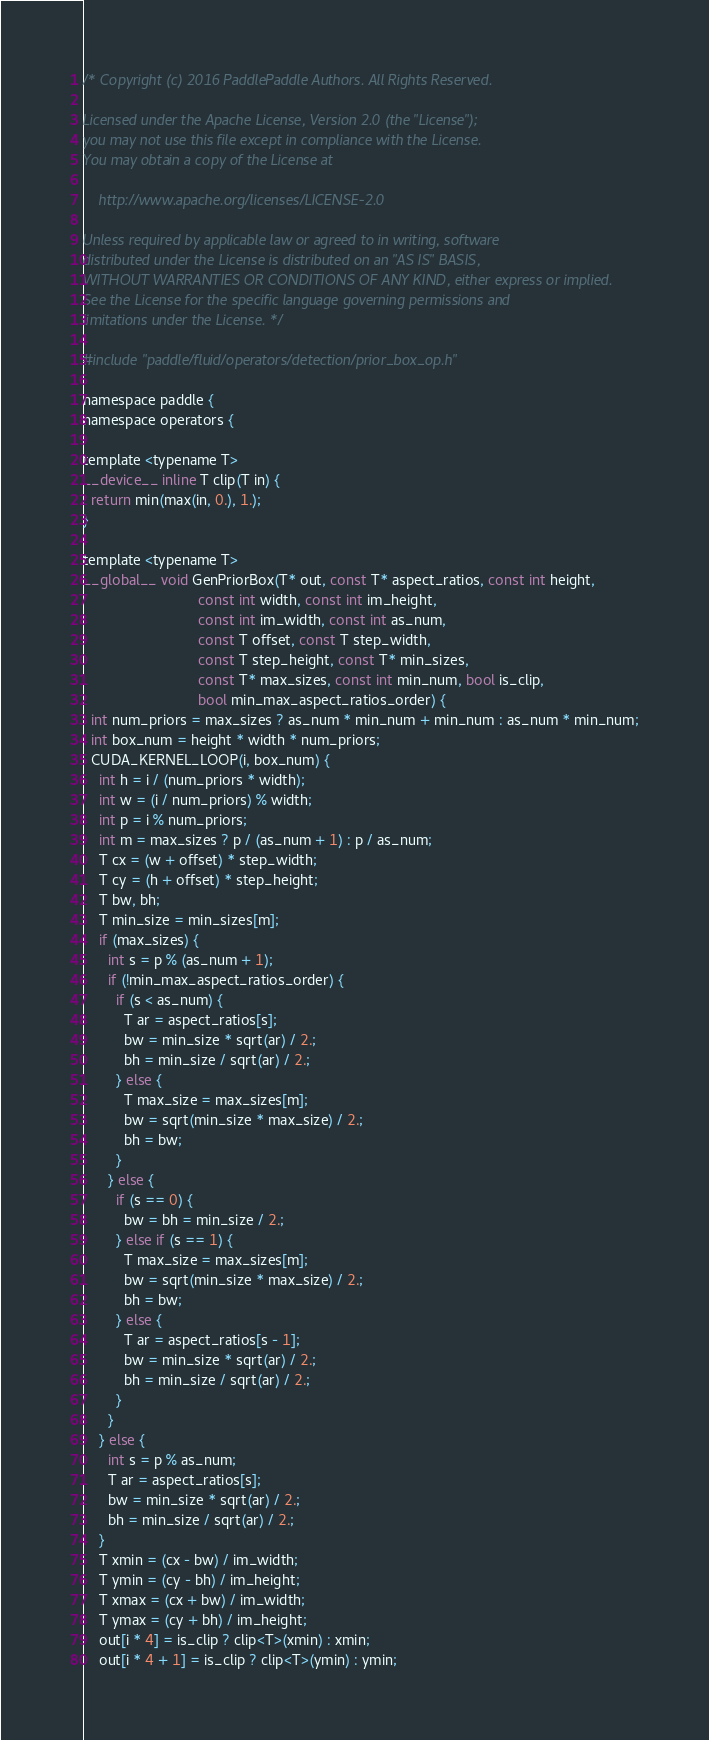Convert code to text. <code><loc_0><loc_0><loc_500><loc_500><_Cuda_>/* Copyright (c) 2016 PaddlePaddle Authors. All Rights Reserved.

Licensed under the Apache License, Version 2.0 (the "License");
you may not use this file except in compliance with the License.
You may obtain a copy of the License at

    http://www.apache.org/licenses/LICENSE-2.0

Unless required by applicable law or agreed to in writing, software
distributed under the License is distributed on an "AS IS" BASIS,
WITHOUT WARRANTIES OR CONDITIONS OF ANY KIND, either express or implied.
See the License for the specific language governing permissions and
limitations under the License. */

#include "paddle/fluid/operators/detection/prior_box_op.h"

namespace paddle {
namespace operators {

template <typename T>
__device__ inline T clip(T in) {
  return min(max(in, 0.), 1.);
}

template <typename T>
__global__ void GenPriorBox(T* out, const T* aspect_ratios, const int height,
                            const int width, const int im_height,
                            const int im_width, const int as_num,
                            const T offset, const T step_width,
                            const T step_height, const T* min_sizes,
                            const T* max_sizes, const int min_num, bool is_clip,
                            bool min_max_aspect_ratios_order) {
  int num_priors = max_sizes ? as_num * min_num + min_num : as_num * min_num;
  int box_num = height * width * num_priors;
  CUDA_KERNEL_LOOP(i, box_num) {
    int h = i / (num_priors * width);
    int w = (i / num_priors) % width;
    int p = i % num_priors;
    int m = max_sizes ? p / (as_num + 1) : p / as_num;
    T cx = (w + offset) * step_width;
    T cy = (h + offset) * step_height;
    T bw, bh;
    T min_size = min_sizes[m];
    if (max_sizes) {
      int s = p % (as_num + 1);
      if (!min_max_aspect_ratios_order) {
        if (s < as_num) {
          T ar = aspect_ratios[s];
          bw = min_size * sqrt(ar) / 2.;
          bh = min_size / sqrt(ar) / 2.;
        } else {
          T max_size = max_sizes[m];
          bw = sqrt(min_size * max_size) / 2.;
          bh = bw;
        }
      } else {
        if (s == 0) {
          bw = bh = min_size / 2.;
        } else if (s == 1) {
          T max_size = max_sizes[m];
          bw = sqrt(min_size * max_size) / 2.;
          bh = bw;
        } else {
          T ar = aspect_ratios[s - 1];
          bw = min_size * sqrt(ar) / 2.;
          bh = min_size / sqrt(ar) / 2.;
        }
      }
    } else {
      int s = p % as_num;
      T ar = aspect_ratios[s];
      bw = min_size * sqrt(ar) / 2.;
      bh = min_size / sqrt(ar) / 2.;
    }
    T xmin = (cx - bw) / im_width;
    T ymin = (cy - bh) / im_height;
    T xmax = (cx + bw) / im_width;
    T ymax = (cy + bh) / im_height;
    out[i * 4] = is_clip ? clip<T>(xmin) : xmin;
    out[i * 4 + 1] = is_clip ? clip<T>(ymin) : ymin;</code> 